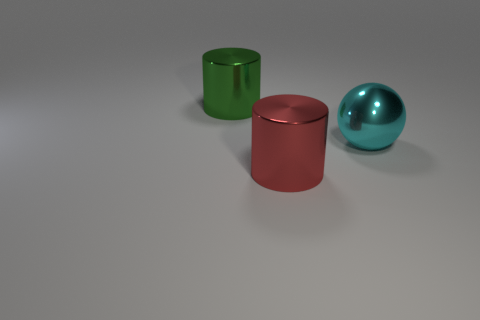Is the number of big cyan metallic spheres that are left of the big metal sphere greater than the number of big green shiny cylinders that are in front of the large green shiny thing?
Give a very brief answer. No. Is the material of the large red object the same as the green cylinder behind the cyan metallic thing?
Your answer should be compact. Yes. How many large cyan metal objects are on the right side of the shiny thing that is on the left side of the large cylinder in front of the cyan metallic object?
Keep it short and to the point. 1. There is a big green thing; is its shape the same as the big shiny object in front of the big cyan ball?
Make the answer very short. Yes. What color is the large thing that is both behind the large red metallic cylinder and in front of the green metal thing?
Ensure brevity in your answer.  Cyan. There is a big cylinder in front of the thing that is left of the large cylinder on the right side of the large green object; what is it made of?
Make the answer very short. Metal. The other metallic thing that is the same shape as the red object is what size?
Ensure brevity in your answer.  Large. Are there the same number of big spheres right of the big metallic sphere and big cyan shiny things?
Offer a terse response. No. Is the size of the metal cylinder in front of the cyan metallic ball the same as the big green shiny cylinder?
Keep it short and to the point. Yes. How many big metal objects are on the left side of the metal sphere?
Give a very brief answer. 2. 